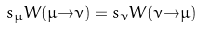Convert formula to latex. <formula><loc_0><loc_0><loc_500><loc_500>s _ { \mu } W ( \mu { \to } \nu ) = s _ { \nu } W ( \nu { \to } \mu )</formula> 